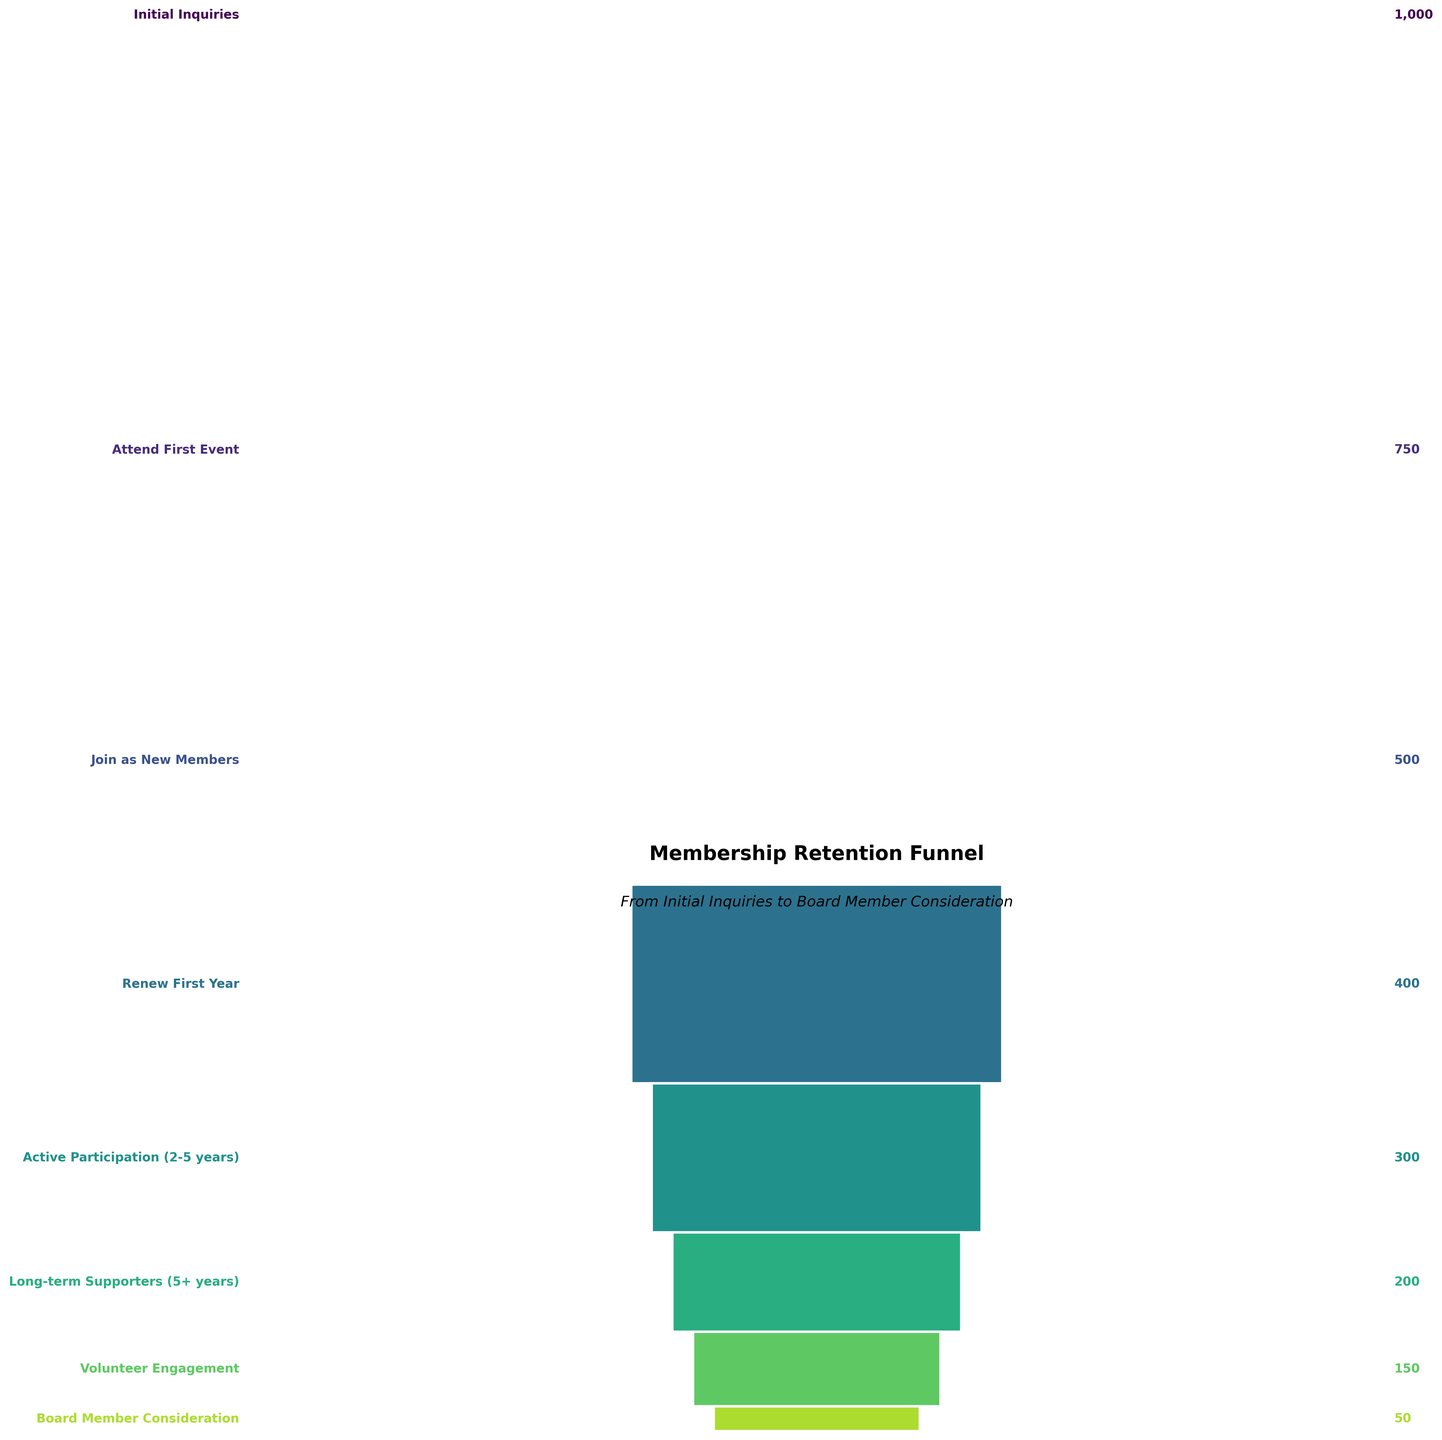How many members started at the Initial Inquiries stage? The first bar in the funnel represents the Initial Inquiries stage. Thus, the number of members started at the Initial Inquiries stage is directly mentioned next to this stage.
Answer: 1000 What's the title of the funnel chart? The title is usually found at the top of the chart.
Answer: Membership Retention Funnel Between which stages do we see the largest drop in membership numbers? To determine the largest drop, calculate the difference in member counts between each consecutive stage and identify the greatest difference. The greatest drop is between 'Initial Inquiries' (1000) and 'Attend First Event' (750), which is a decrease of 250 members.
Answer: Initial Inquiries to Attend First Event How many members transitioned from Active Participation to Long-term Supporters? The number of members transitioning from Active Participation to Long-term Supporters can be determined by subtracting the Long-term Supporters (200 members) from the Active Participation stage (300 members).
Answer: 100 By how many members does the number of Volunteer Engagement decrease from Long-term Supporters? The number of Volunteer Engagement (150 members) is subtracted from the number of Long-term Supporters (200 members) resulting in the difference.
Answer: 50 Which stage has the least number of members? The stage with the smallest bar represents the fewest members, which is Board Member Consideration with 50 members.
Answer: Board Member Consideration What percentage of new members renew after the first year? To find the percentage, divide the number of members who Renew First Year (400) by the number of New Members (500) and multiply by 100. 400 / 500 * 100 = 80%.
Answer: 80% Compare the number of members who Join as New Members to those who end up becoming Board Members. Subtract the number of Board Members (50) from those who Join as New Members (500). 500 - 50 = 450.
Answer: 450 Where does the stage Active Participation rank in terms of member count compared to other stages? Rank the stages by their number of members: Initial Inquiries (1000), Attend First Event (750), Join as New Members (500), Renew First Year (400), Active Participation (300), Long-term Supporters (200), Volunteer Engagement (150), Board Member Consideration (50). Active Participation is fifth in terms of member count.
Answer: Fifth From New Members (Join as New Members) to Active Participation, by what percentage did the membership decrease? Calculate the percentage decrease: [(500 - 300) / 500] * 100 = 40%.
Answer: 40% 